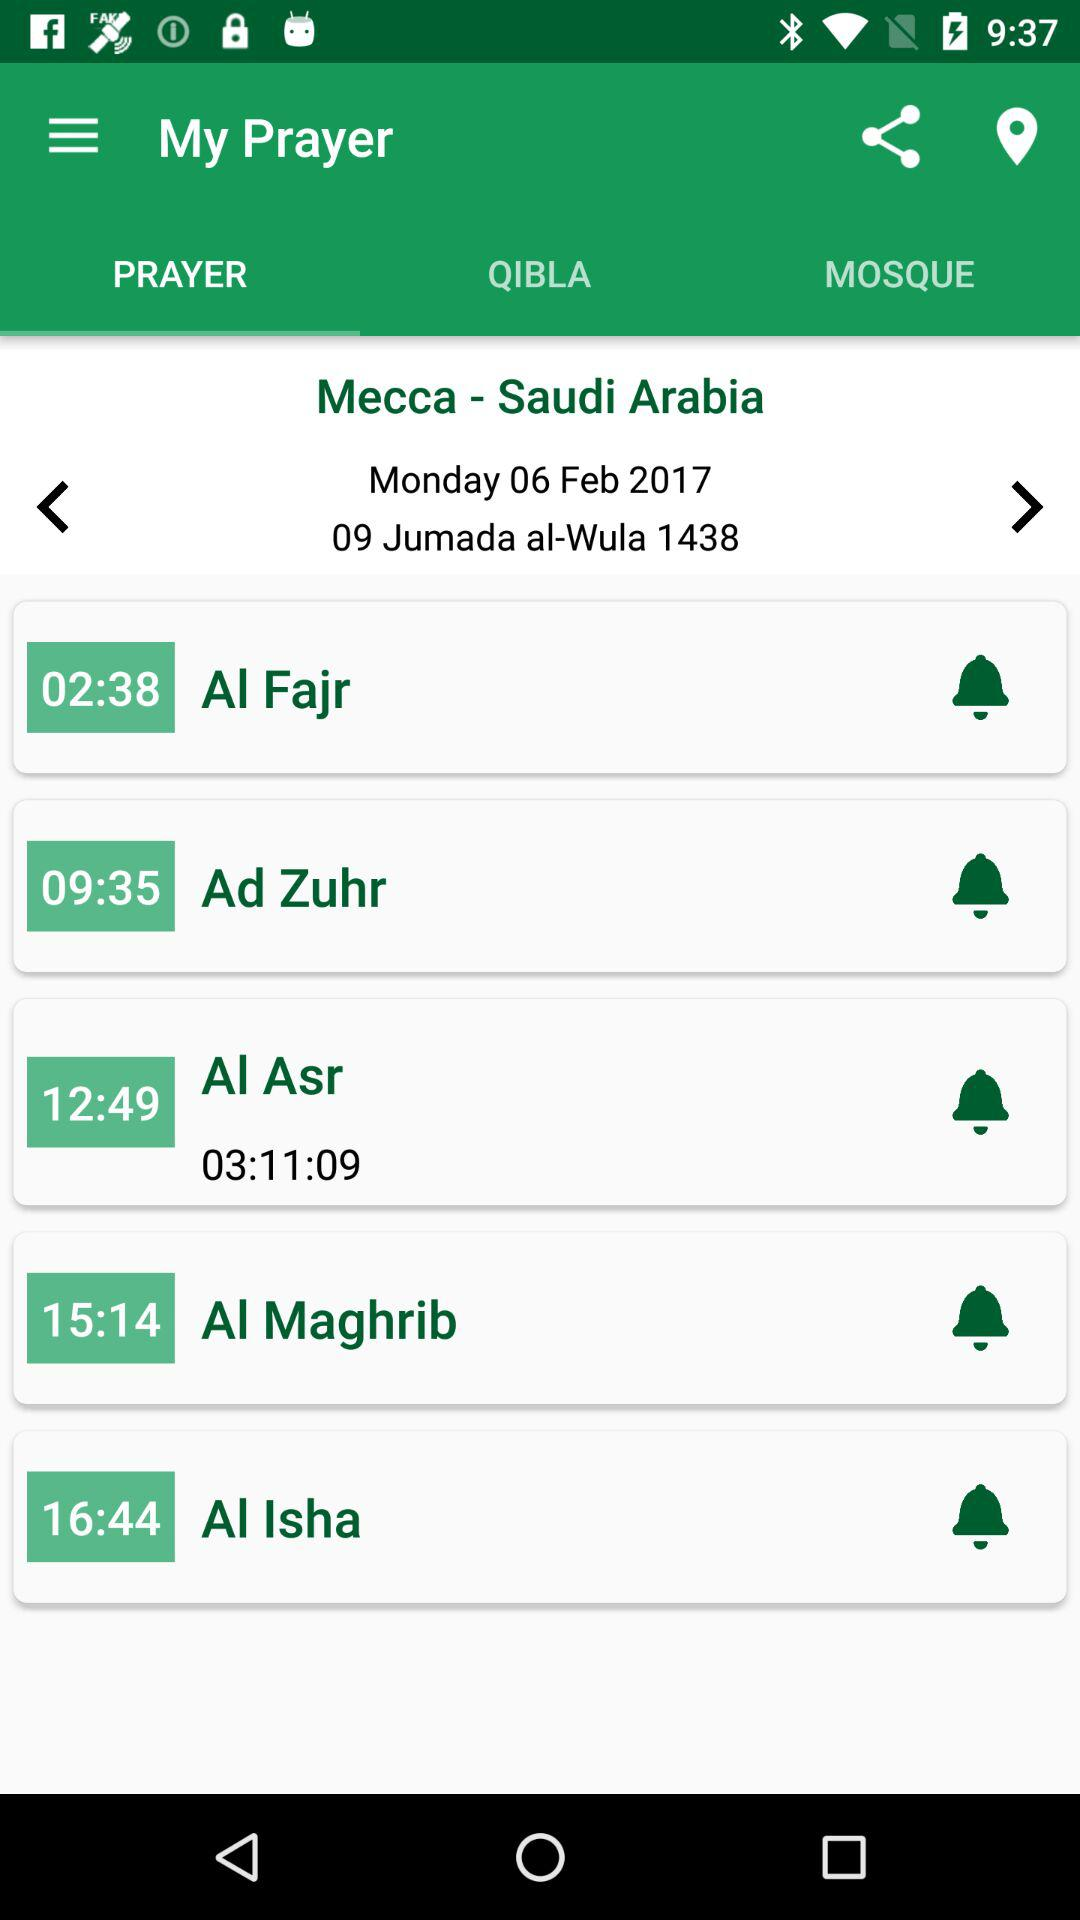What is the selected date? The selected date is Monday, February 6, 2017. 